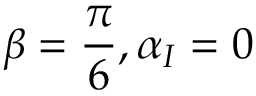<formula> <loc_0><loc_0><loc_500><loc_500>\beta = \frac { \pi } { 6 } , \alpha _ { I } = 0</formula> 